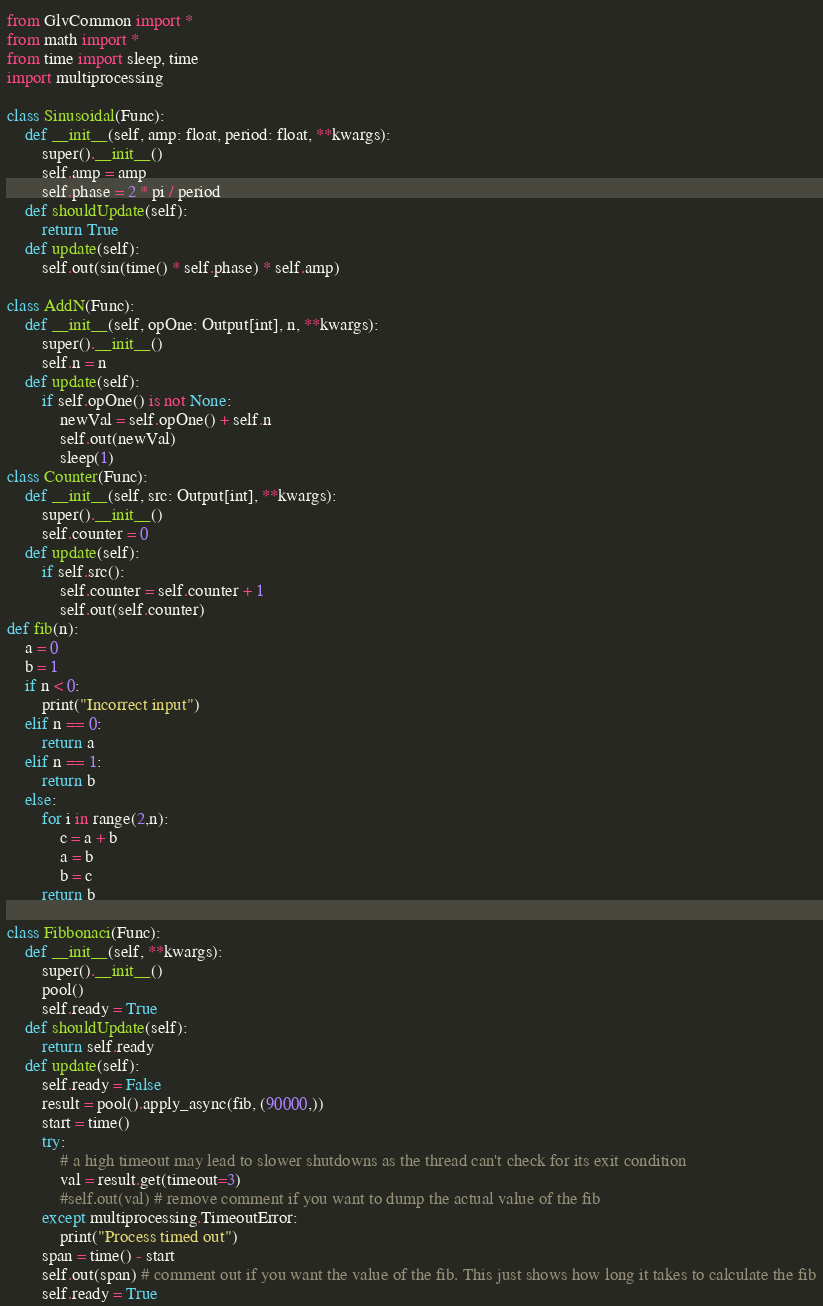Convert code to text. <code><loc_0><loc_0><loc_500><loc_500><_Python_>from GlvCommon import *
from math import *
from time import sleep, time
import multiprocessing

class Sinusoidal(Func):
    def __init__(self, amp: float, period: float, **kwargs):
        super().__init__()
        self.amp = amp
        self.phase = 2 * pi / period
    def shouldUpdate(self):
        return True
    def update(self):
        self.out(sin(time() * self.phase) * self.amp)
    
class AddN(Func):
    def __init__(self, opOne: Output[int], n, **kwargs):
        super().__init__()
        self.n = n
    def update(self):
        if self.opOne() is not None:
            newVal = self.opOne() + self.n
            self.out(newVal)
            sleep(1)
class Counter(Func):
    def __init__(self, src: Output[int], **kwargs):
        super().__init__()
        self.counter = 0
    def update(self):
        if self.src():
            self.counter = self.counter + 1
            self.out(self.counter)
def fib(n): 
    a = 0
    b = 1
    if n < 0: 
        print("Incorrect input") 
    elif n == 0: 
        return a 
    elif n == 1: 
        return b 
    else: 
        for i in range(2,n): 
            c = a + b 
            a = b 
            b = c 
        return b

class Fibbonaci(Func):
    def __init__(self, **kwargs):
        super().__init__()
        pool()
        self.ready = True
    def shouldUpdate(self):
        return self.ready
    def update(self):
        self.ready = False
        result = pool().apply_async(fib, (90000,))
        start = time()
        try:
            # a high timeout may lead to slower shutdowns as the thread can't check for its exit condition
            val = result.get(timeout=3)
            #self.out(val) # remove comment if you want to dump the actual value of the fib
        except multiprocessing.TimeoutError:
            print("Process timed out")
        span = time() - start
        self.out(span) # comment out if you want the value of the fib. This just shows how long it takes to calculate the fib
        self.ready = True
</code> 